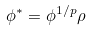<formula> <loc_0><loc_0><loc_500><loc_500>\phi ^ { * } = \phi ^ { 1 / p } \rho \,</formula> 